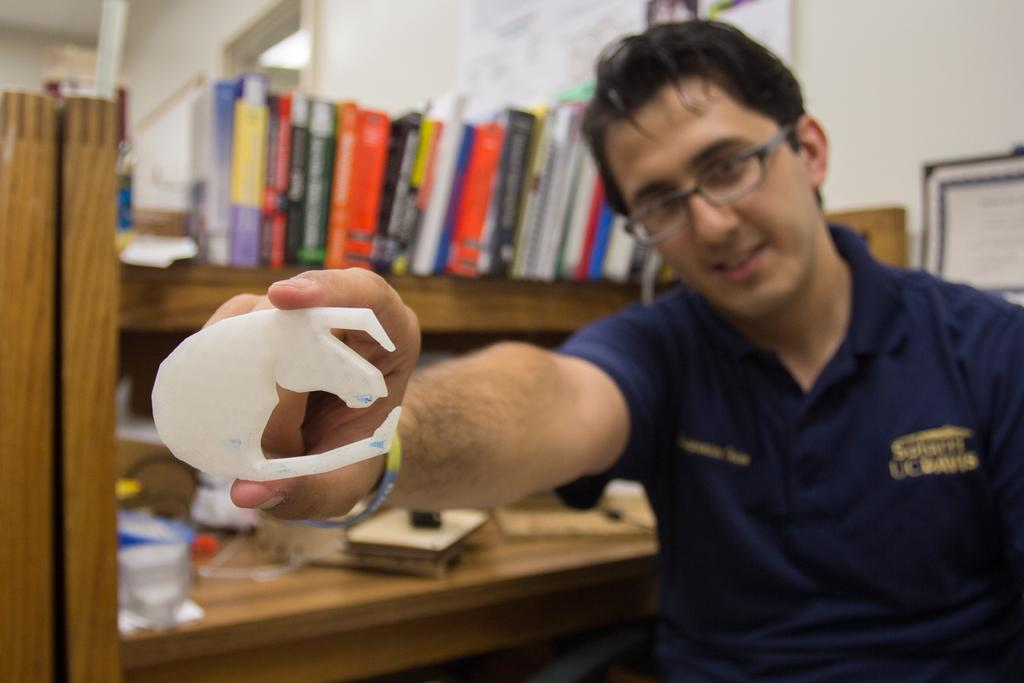What is the person holding in the image? There is a person holding an object in the image. What type of items can be seen on shelves in the image? There are books on shelves in the image. What is on the table in the image? There is a table with objects on it in the image. What can be seen hanging on the wall in the image? There is a photo frame on the wall in the image. How does the person's wealth affect the objects in the image? The image does not provide any information about the person's wealth, so we cannot determine how it might affect the objects in the image. 